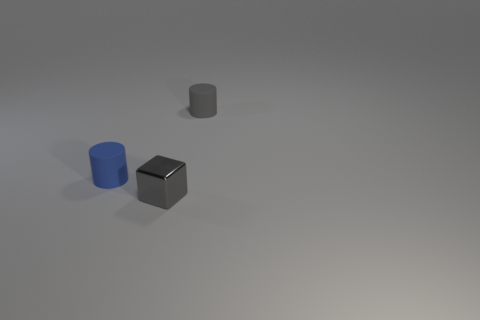Add 1 gray objects. How many objects exist? 4 Subtract all cylinders. How many objects are left? 1 Subtract all small gray matte cylinders. Subtract all big brown shiny cylinders. How many objects are left? 2 Add 3 gray cylinders. How many gray cylinders are left? 4 Add 2 tiny gray things. How many tiny gray things exist? 4 Subtract 0 cyan cylinders. How many objects are left? 3 